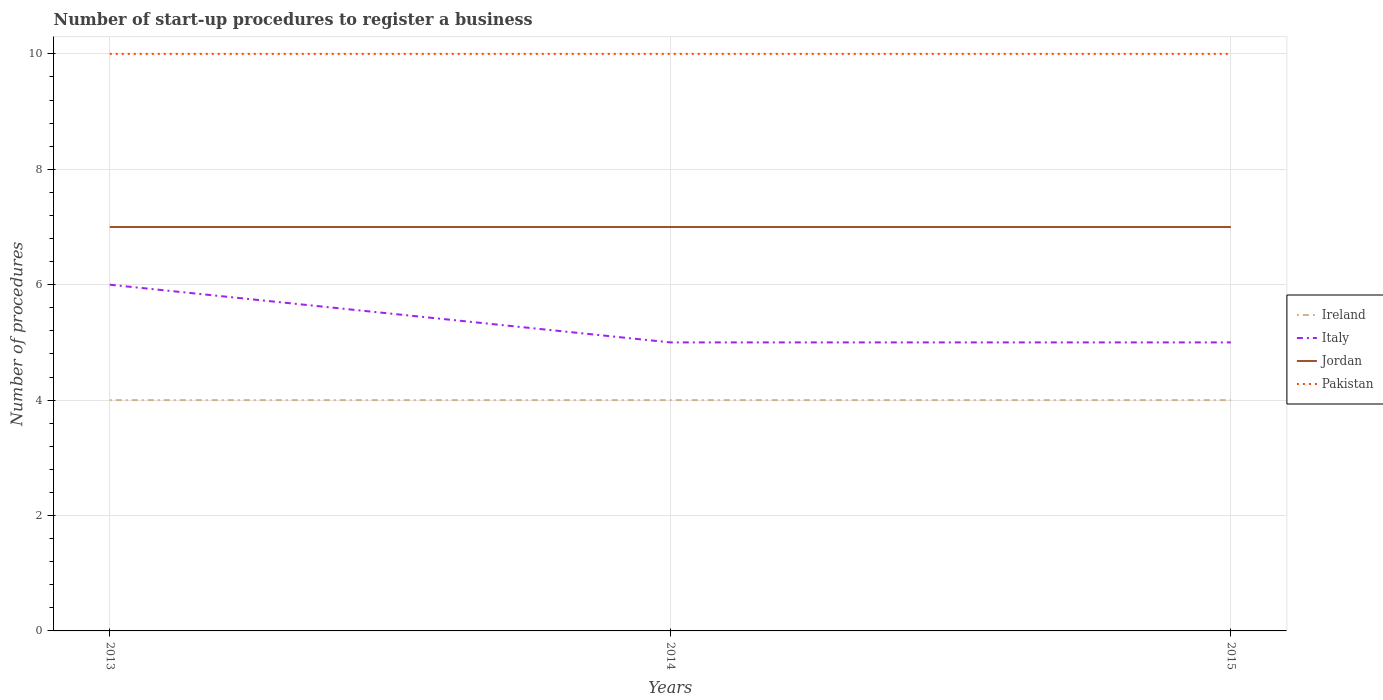How many different coloured lines are there?
Offer a very short reply. 4. Is the number of lines equal to the number of legend labels?
Your response must be concise. Yes. Across all years, what is the maximum number of procedures required to register a business in Jordan?
Keep it short and to the point. 7. What is the total number of procedures required to register a business in Jordan in the graph?
Your response must be concise. 0. Is the number of procedures required to register a business in Pakistan strictly greater than the number of procedures required to register a business in Ireland over the years?
Ensure brevity in your answer.  No. Does the graph contain grids?
Offer a terse response. Yes. How are the legend labels stacked?
Your answer should be very brief. Vertical. What is the title of the graph?
Your response must be concise. Number of start-up procedures to register a business. What is the label or title of the Y-axis?
Provide a short and direct response. Number of procedures. What is the Number of procedures in Ireland in 2013?
Make the answer very short. 4. What is the Number of procedures of Jordan in 2013?
Give a very brief answer. 7. What is the Number of procedures in Pakistan in 2013?
Provide a short and direct response. 10. What is the Number of procedures of Ireland in 2014?
Give a very brief answer. 4. What is the Number of procedures in Jordan in 2014?
Provide a short and direct response. 7. What is the Number of procedures in Pakistan in 2014?
Make the answer very short. 10. Across all years, what is the maximum Number of procedures of Ireland?
Keep it short and to the point. 4. Across all years, what is the maximum Number of procedures of Italy?
Provide a short and direct response. 6. Across all years, what is the maximum Number of procedures in Jordan?
Offer a terse response. 7. Across all years, what is the minimum Number of procedures in Jordan?
Keep it short and to the point. 7. Across all years, what is the minimum Number of procedures of Pakistan?
Make the answer very short. 10. What is the total Number of procedures of Ireland in the graph?
Make the answer very short. 12. What is the difference between the Number of procedures of Ireland in 2013 and that in 2014?
Ensure brevity in your answer.  0. What is the difference between the Number of procedures in Italy in 2013 and that in 2014?
Make the answer very short. 1. What is the difference between the Number of procedures in Ireland in 2013 and that in 2015?
Make the answer very short. 0. What is the difference between the Number of procedures of Ireland in 2014 and that in 2015?
Your response must be concise. 0. What is the difference between the Number of procedures of Italy in 2013 and the Number of procedures of Jordan in 2014?
Your response must be concise. -1. What is the difference between the Number of procedures of Ireland in 2013 and the Number of procedures of Italy in 2015?
Your answer should be very brief. -1. What is the difference between the Number of procedures of Ireland in 2013 and the Number of procedures of Jordan in 2015?
Offer a terse response. -3. What is the difference between the Number of procedures of Italy in 2013 and the Number of procedures of Pakistan in 2015?
Provide a short and direct response. -4. What is the difference between the Number of procedures in Italy in 2014 and the Number of procedures in Jordan in 2015?
Your answer should be compact. -2. What is the average Number of procedures in Ireland per year?
Provide a succinct answer. 4. What is the average Number of procedures of Italy per year?
Offer a very short reply. 5.33. What is the average Number of procedures of Pakistan per year?
Make the answer very short. 10. In the year 2013, what is the difference between the Number of procedures of Ireland and Number of procedures of Italy?
Offer a terse response. -2. In the year 2013, what is the difference between the Number of procedures in Ireland and Number of procedures in Jordan?
Provide a short and direct response. -3. In the year 2013, what is the difference between the Number of procedures in Italy and Number of procedures in Pakistan?
Your answer should be very brief. -4. In the year 2014, what is the difference between the Number of procedures of Ireland and Number of procedures of Jordan?
Make the answer very short. -3. In the year 2015, what is the difference between the Number of procedures in Ireland and Number of procedures in Italy?
Offer a very short reply. -1. In the year 2015, what is the difference between the Number of procedures in Ireland and Number of procedures in Pakistan?
Your answer should be very brief. -6. In the year 2015, what is the difference between the Number of procedures of Italy and Number of procedures of Pakistan?
Your answer should be compact. -5. What is the ratio of the Number of procedures of Italy in 2013 to that in 2014?
Make the answer very short. 1.2. What is the ratio of the Number of procedures of Pakistan in 2013 to that in 2014?
Offer a very short reply. 1. What is the ratio of the Number of procedures of Italy in 2013 to that in 2015?
Your answer should be compact. 1.2. What is the ratio of the Number of procedures in Ireland in 2014 to that in 2015?
Give a very brief answer. 1. What is the difference between the highest and the second highest Number of procedures of Ireland?
Give a very brief answer. 0. What is the difference between the highest and the second highest Number of procedures in Italy?
Provide a short and direct response. 1. What is the difference between the highest and the second highest Number of procedures in Jordan?
Make the answer very short. 0. What is the difference between the highest and the lowest Number of procedures in Italy?
Offer a terse response. 1. 